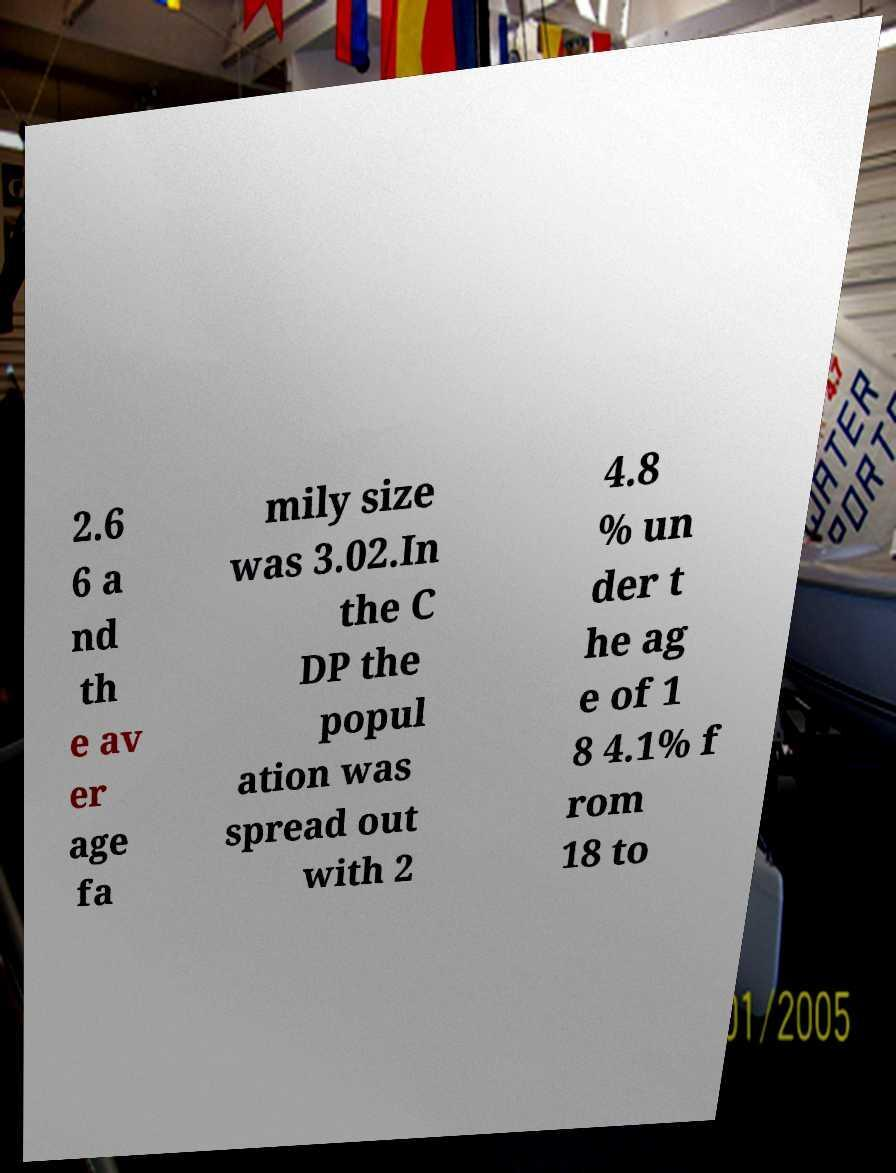Can you accurately transcribe the text from the provided image for me? 2.6 6 a nd th e av er age fa mily size was 3.02.In the C DP the popul ation was spread out with 2 4.8 % un der t he ag e of 1 8 4.1% f rom 18 to 